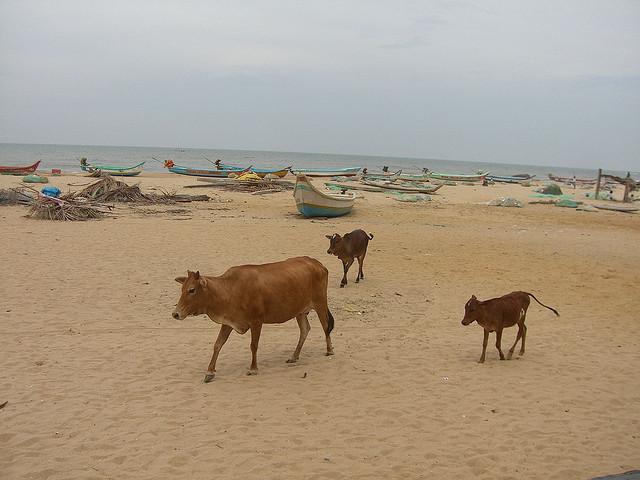How many cows are there?
Give a very brief answer. 3. 